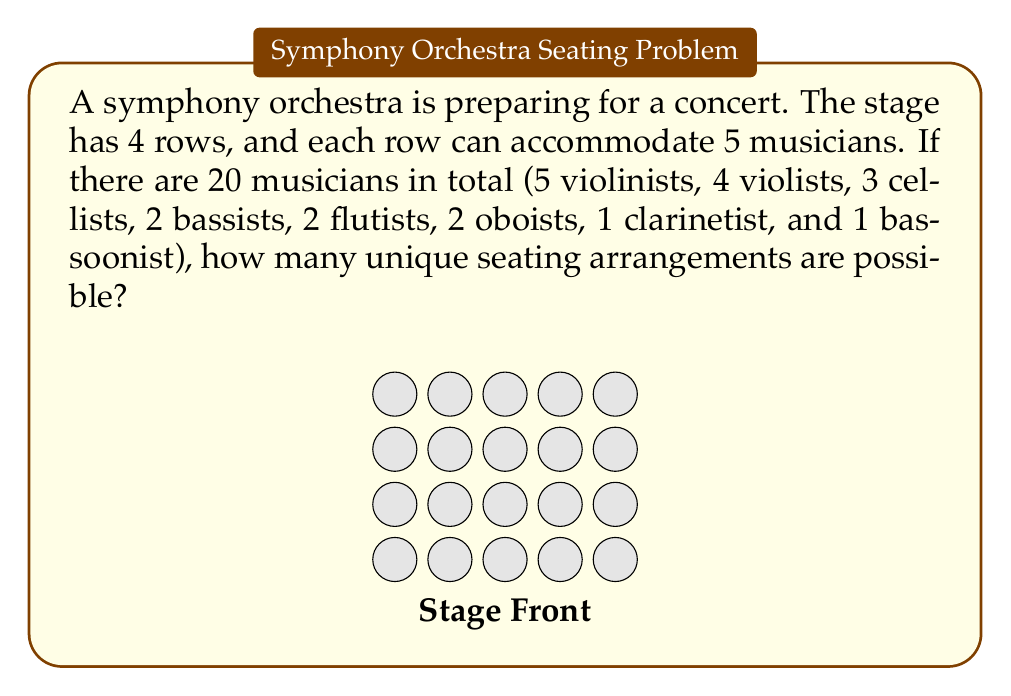Show me your answer to this math problem. Let's approach this step-by-step:

1) First, we need to understand that this is a permutation problem. We are arranging 20 distinct musicians in 20 distinct positions.

2) The total number of ways to arrange 20 distinct objects is 20! (20 factorial).

3) However, we need to account for the fact that some musicians play the same instrument. These musicians are indistinguishable for the purposes of this problem.

4) For each group of identical musicians, we need to divide by the number of ways to arrange them among themselves:
   - 5! for the violinists
   - 4! for the violists
   - 3! for the cellists
   - 2! for the bassists
   - 2! for the flutists
   - 2! for the oboists

5) The clarinetist and bassoonist are single, so they don't affect our calculation.

6) Therefore, the total number of unique arrangements is:

   $$\frac{20!}{5! \cdot 4! \cdot 3! \cdot 2! \cdot 2! \cdot 2!}$$

7) Let's calculate this:
   $$\begin{align}
   &= \frac{20!}{(5! \cdot 4! \cdot 3! \cdot 2! \cdot 2! \cdot 2!)} \\
   &= \frac{2432902008176640000}{(120 \cdot 24 \cdot 6 \cdot 2 \cdot 2 \cdot 2)} \\
   &= \frac{2432902008176640000}{13824} \\
   &= 176064650745600
   \end{align}$$

Thus, there are 176,064,650,745,600 unique seating arrangements possible.
Answer: 176,064,650,745,600 